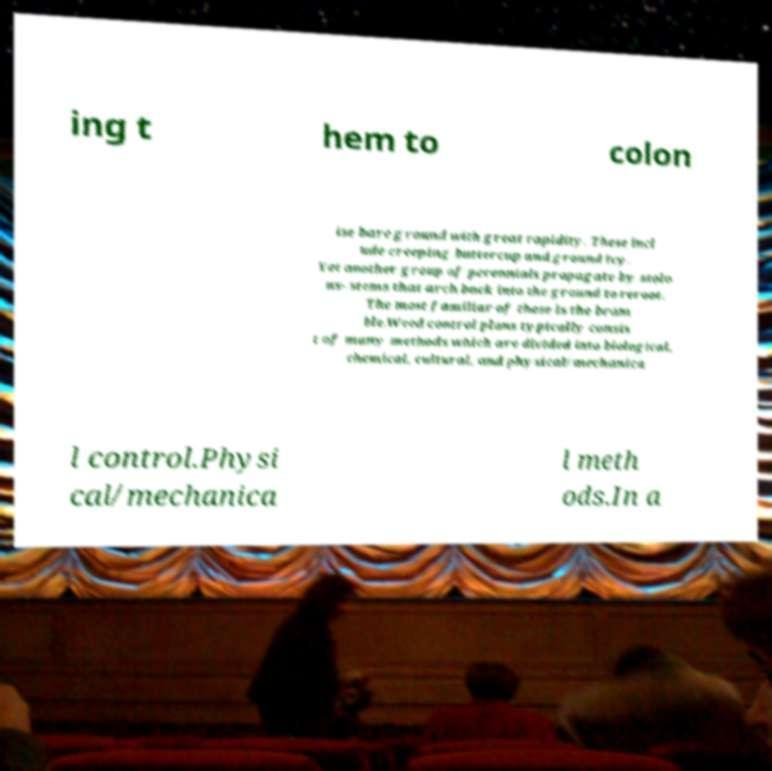I need the written content from this picture converted into text. Can you do that? ing t hem to colon ise bare ground with great rapidity. These incl ude creeping buttercup and ground ivy. Yet another group of perennials propagate by stolo ns- stems that arch back into the ground to reroot. The most familiar of these is the bram ble.Weed control plans typically consis t of many methods which are divided into biological, chemical, cultural, and physical/mechanica l control.Physi cal/mechanica l meth ods.In a 